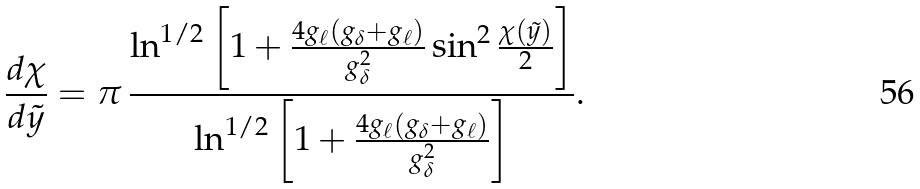Convert formula to latex. <formula><loc_0><loc_0><loc_500><loc_500>\frac { d \chi } { d \tilde { y } } = \pi \, \frac { \ln ^ { 1 / 2 } \left [ 1 + \frac { 4 g _ { \ell } \left ( g _ { \delta } + g _ { \ell } \right ) } { g _ { \delta } ^ { 2 } } \sin ^ { 2 } \frac { \chi ( \tilde { y } ) } { 2 } \right ] } { \ln ^ { 1 / 2 } \left [ 1 + \frac { 4 g _ { \ell } \left ( g _ { \delta } + g _ { \ell } \right ) } { g _ { \delta } ^ { 2 } } \right ] } .</formula> 